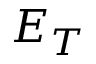Convert formula to latex. <formula><loc_0><loc_0><loc_500><loc_500>E _ { T }</formula> 